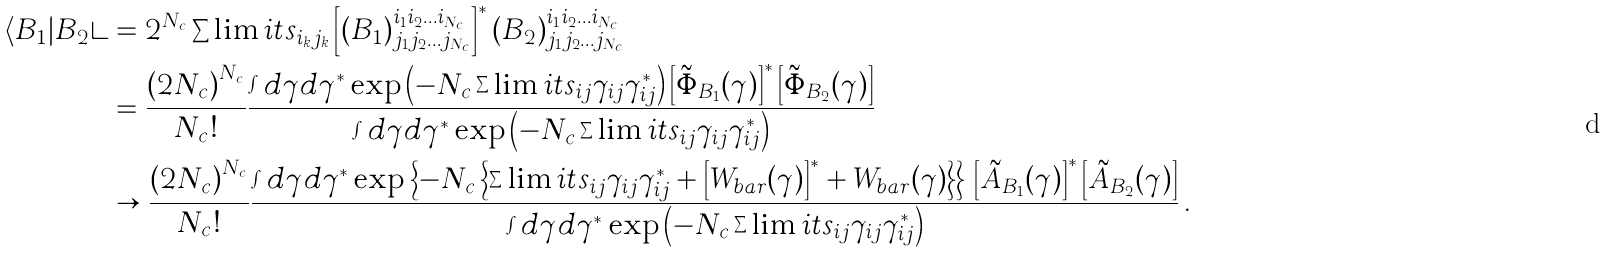Convert formula to latex. <formula><loc_0><loc_0><loc_500><loc_500>\langle B _ { 1 } | B _ { 2 } \rangle & = 2 ^ { N _ { c } } \sum \lim i t s _ { i _ { k } j _ { k } } \left [ \left ( B _ { 1 } \right ) _ { j _ { 1 } j _ { 2 } \dots j _ { N _ { c } } } ^ { i _ { 1 } i _ { 2 } \dots i _ { N _ { c } } } \right ] ^ { \ast } \left ( B _ { 2 } \right ) _ { j _ { 1 } j _ { 2 } \dots j _ { N _ { c } } } ^ { i _ { 1 } i _ { 2 } \dots i _ { N _ { c } } } \\ & = \frac { \left ( 2 N _ { c } \right ) ^ { N _ { c } } } { N _ { c } ! } \frac { \int d \gamma d \gamma ^ { \ast } \exp \left ( - N _ { c } \sum \lim i t s _ { i j } \gamma _ { i j } \gamma _ { i j } ^ { \ast } \right ) \left [ \tilde { \Phi } _ { B _ { 1 } } ( \gamma ) \right ] ^ { \ast } \left [ \tilde { \Phi } _ { B _ { 2 } } ( \gamma ) \right ] } { \int d \gamma d \gamma ^ { \ast } \exp \left ( - N _ { c } \sum \lim i t s _ { i j } \gamma _ { i j } \gamma _ { i j } ^ { \ast } \right ) } \\ & \rightarrow \frac { \left ( 2 N _ { c } \right ) ^ { N _ { c } } } { N _ { c } ! } \frac { \int d \gamma d \gamma ^ { \ast } \exp \left \{ - N _ { c } \left \{ \sum \lim i t s _ { i j } \gamma _ { i j } \gamma _ { i j } ^ { \ast } + \left [ W _ { b a r } ( \gamma ) \right ] ^ { \ast } + W _ { b a r } ( \gamma ) \right \} \right \} \, \left [ \tilde { A } _ { B _ { 1 } } ( \gamma ) \right ] ^ { \ast } \left [ \tilde { A } _ { B _ { 2 } } ( \gamma ) \right ] } { \int d \gamma d \gamma ^ { \ast } \exp \left ( - N _ { c } \sum \lim i t s _ { i j } \gamma _ { i j } \gamma _ { i j } ^ { \ast } \right ) } \, .</formula> 